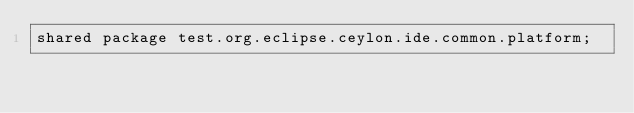<code> <loc_0><loc_0><loc_500><loc_500><_Ceylon_>shared package test.org.eclipse.ceylon.ide.common.platform;
</code> 